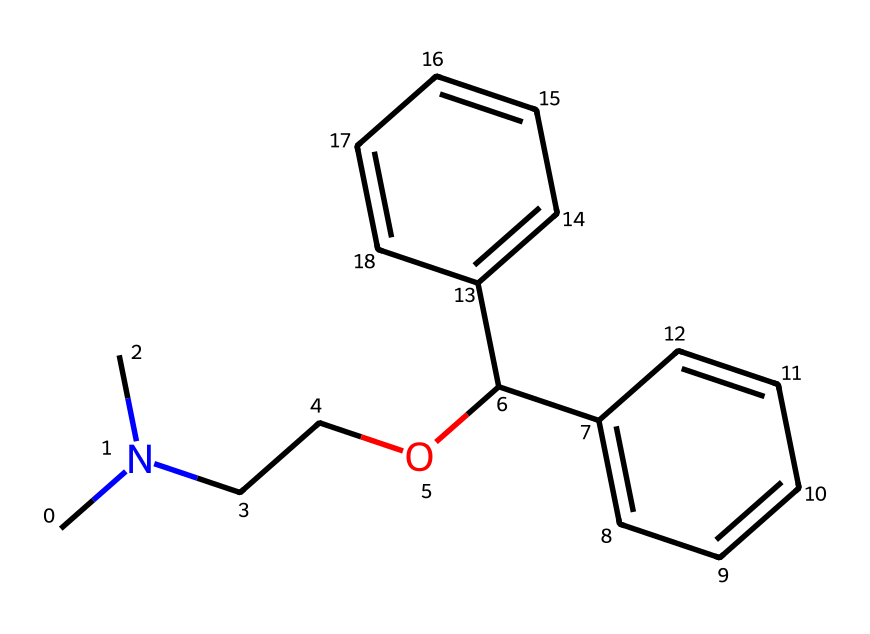What is the molecular formula of diphenhydramine? To find the molecular formula, you count the atoms of each element in the SMILES representation. In this case, there are 17 carbon (C) atoms, 21 hydrogen (H) atoms, and 1 nitrogen (N) atom, leading to the formula C17H21N.
Answer: C17H21N How many rings are present in the diphenhydramine structure? In the provided SMILES, there are two aromatic rings represented by the "c" atoms ("c1ccccc1") which denotes the benzene structures. This indicates that there are 2 rings in total.
Answer: 2 Does diphenhydramine contain any heteroatoms? A heteroatom is any atom in a compound that is not carbon or hydrogen. In this case, diphenhydramine has one nitrogen atom that qualifies as a heteroatom, making it a part of this molecule.
Answer: yes What type of functional groups are present in diphenhydramine? The SMILES representation shows the presence of an alkyl amine (due to the nitrogen atom bonded to alkyl chains) and an ether functional group (the part "OC" indicates an oxygen bonded to carbon). Thus, these two functional groups are present.
Answer: alkyl amine and ether Is diphenhydramine a flammable liquid? Diphenhydramine is classified as a flammable liquid due to its organic nature and the presence of carbon-hydrogen bonds that can combust under the right conditions. Additionally, its volatility at certain temperatures contributes to its flammability.
Answer: yes What is the significance of the nitrogen atom in diphenhydramine? The nitrogen atom in diphenhydramine is significant as it makes the compound an amine, contributing to its properties as an antihistamine. It affects how the drug interacts with receptors and its overall biological activity.
Answer: amine How many types of atoms are there in diphenhydramine? In the molecular structure of diphenhydramine, we can observe three types of atoms: carbon (C), hydrogen (H), and nitrogen (N). Therefore, the count is based on these distinct atoms.
Answer: 3 